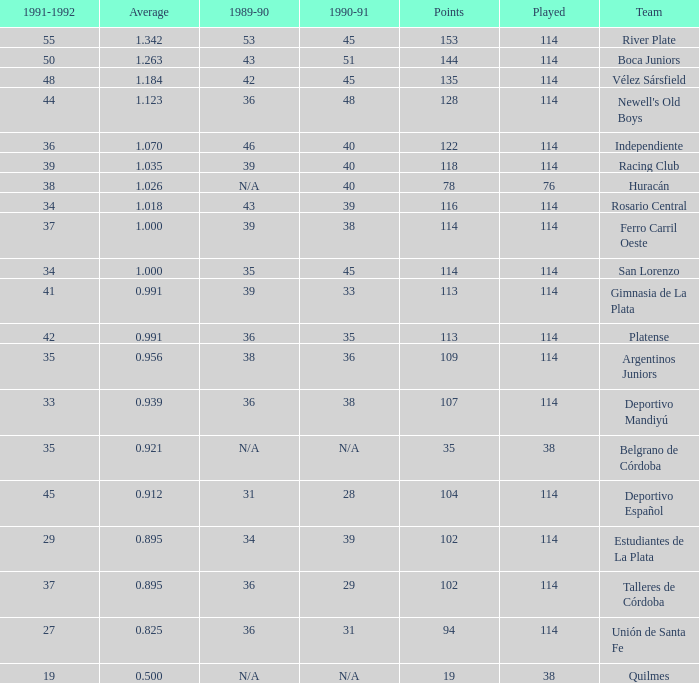How much Played has an Average smaller than 0.9390000000000001, and a 1990-91 of 28? 1.0. 